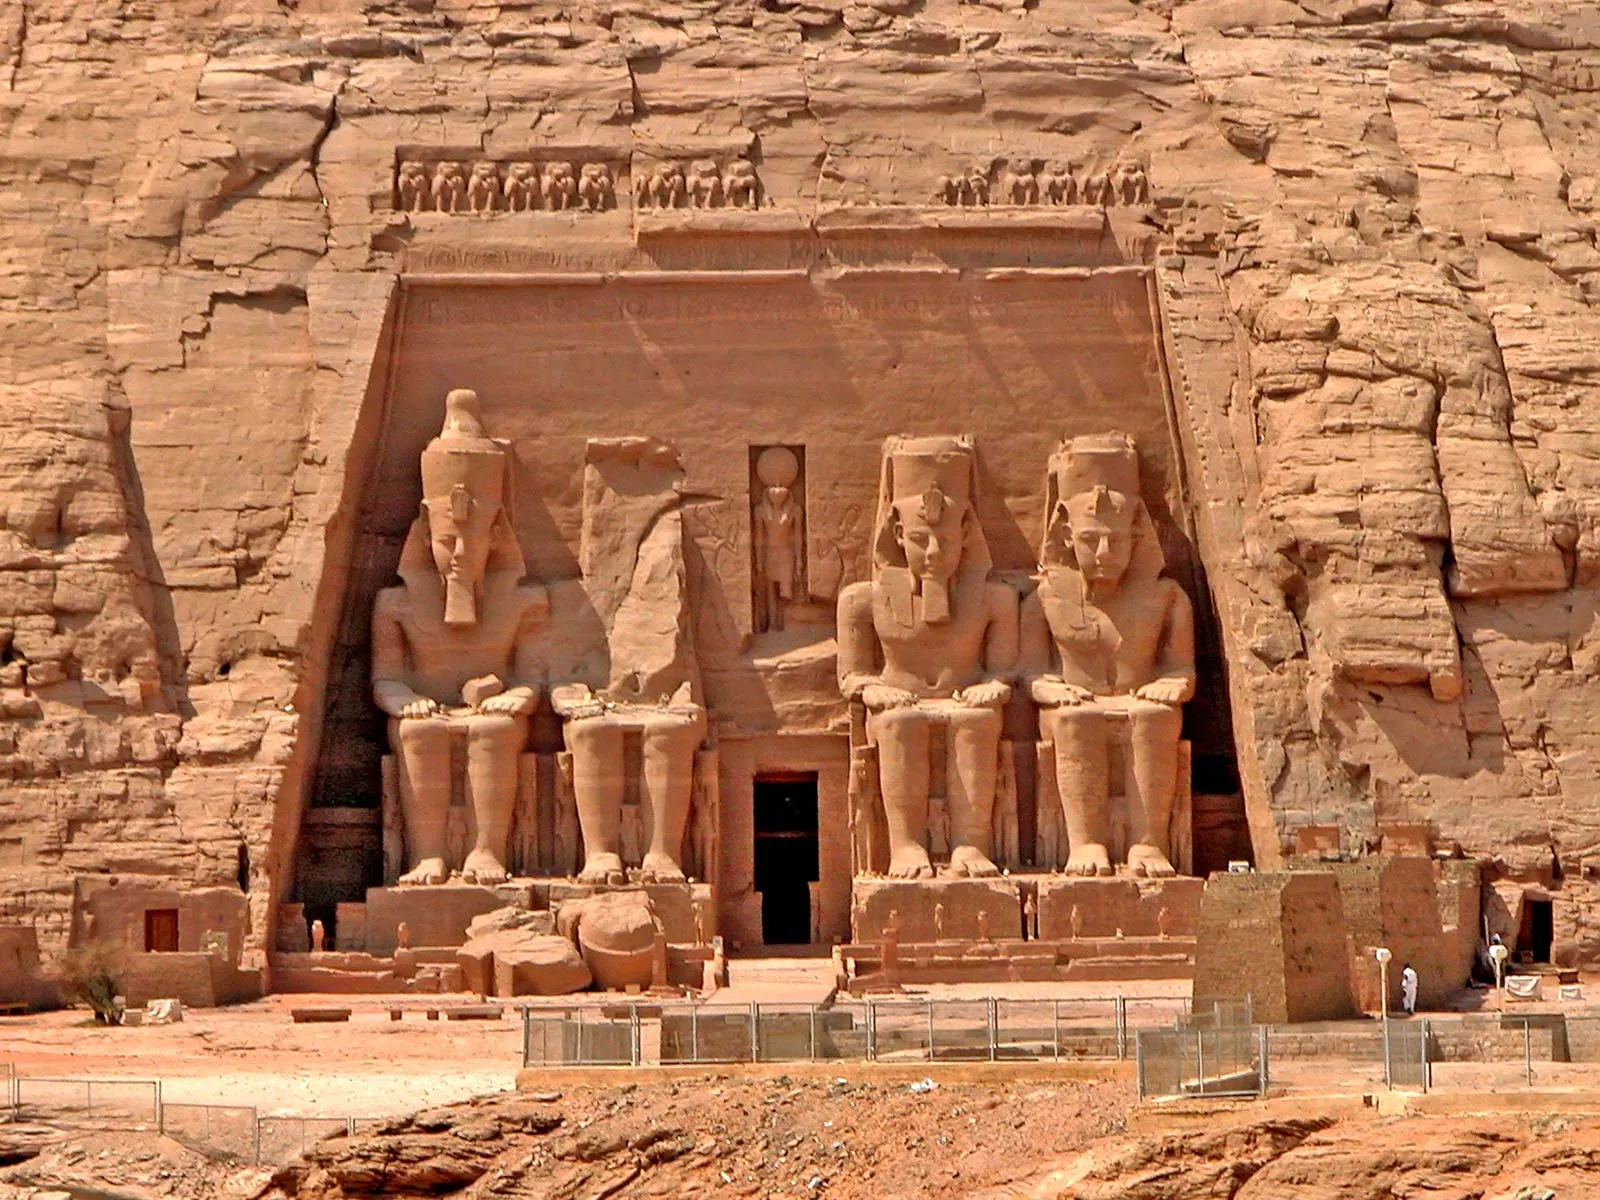Describe a vivid scene of an ancient ceremony led by Ramesses II at the Abu Simbel temple. At dawn, the sun rises over the horizon, casting a golden glow upon the Abu Simbel temple. The air is filled with the rhythmic beating of drums and the melodious chants of priests. Ramesses II, adorned in opulent robes and a grand headdress, stands majestically at the temple's entrance. He raises his arms, and the crowd of worshippers gathers, their eyes filled with reverence. The priests move gracefully, carrying sacred relics and offerings - baskets of fruits, jars of wine, and incense burners, filling the air with fragrant smoke. As the sun aligns perfectly with the inner sanctum, illuminating the statues of the gods, Ramesses II steps forward, chanting a powerful prayer. The crowd responds in unison, their voices echoing through the cavernous temple. A sense of divine presence and unity fills the space, and the ceremony reaches its climax as offerings are presented to the gods. The blessings bestowed upon the pharaoh and his people mark another chapter in the glorious legacy of ancient Egypt. 